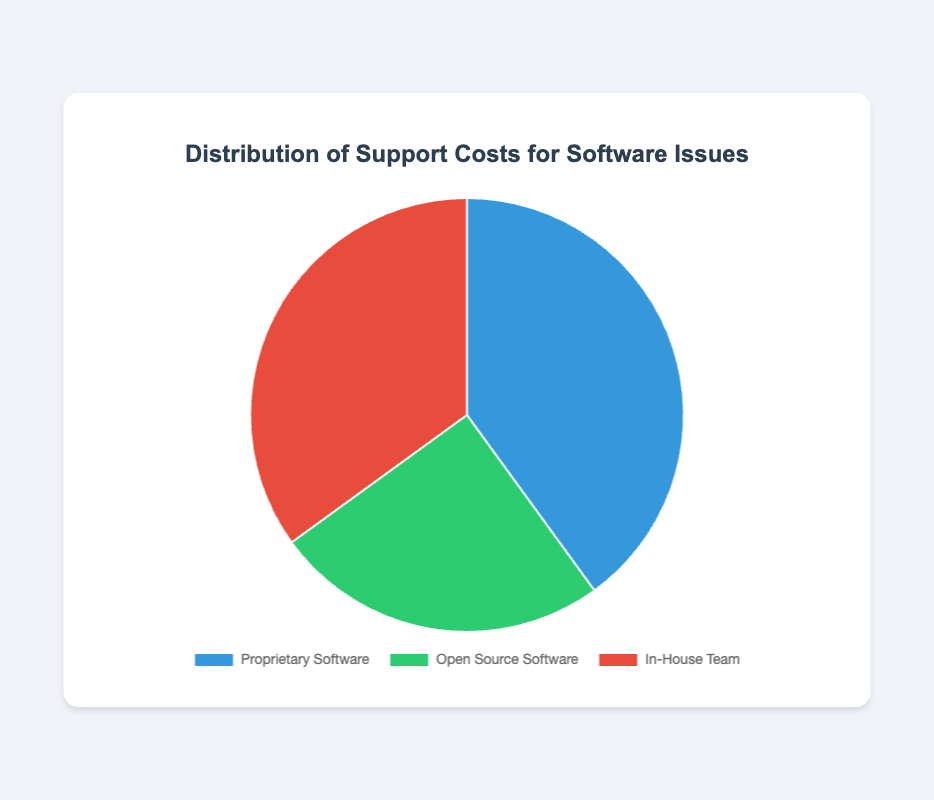What percentage of support costs is attributed to proprietary software? The pie chart shows that the section labeled "Proprietary Software" represents 40% of the support costs.
Answer: 40% How does the support cost for an in-house team compare to that of open source software? The pie chart shows that the in-house team costs are 35%, whereas the open source software costs are 25%. Therefore, the in-house team support cost is higher than that of open source software by 10%.
Answer: In-house team support cost is 10% higher What is the combined percentage of support costs for proprietary software and open source software? Summing up the percentages for proprietary software (40%) and open source software (25%) results in a combined total. 40% + 25% = 65%
Answer: 65% Which segment has the smallest representation in the distribution of support costs? The pie chart visually indicates that the section labeled "Open Source Software" has the smallest share, at 25%.
Answer: Open Source Software By how much does the support cost for proprietary software exceed that of open source software? The pie chart shows proprietary software at 40% and open source software at 25%. Subtracting the smaller percentage from the larger one gives: 40% - 25% = 15%
Answer: 15% What is the percentage difference between the largest and smallest segments in the distribution of support costs? The largest segment is proprietary software at 40%, and the smallest segment is open source software at 25%. The difference between these two percentages is: 40% - 25% = 15%
Answer: 15% Which support cost category is represented by the red section of the pie chart? The pie chart uses color to differentiate between categories. The red section corresponds to the "In-House Team" category.
Answer: In-House Team If we consider the support costs for both open source software and in-house team together, what percentage of the total do they make up? Adding the support cost percentages for open source software (25%) and in-house team (35%) results in: 25% + 35% = 60%
Answer: 60% What proportion of the total support costs is attributed to non-proprietary solutions (combining open source software and in-house team)? The percentages for open source software and in-house team are 25% and 35%, respectively. Summing these gives: 25% + 35% = 60%
Answer: 60% Which category would you infer as having the highest total support costs visualized by the largest segment in the pie chart? By visual inspection, the proprietary software segment appears larger than the others, making it the largest category with 40%.
Answer: Proprietary Software 